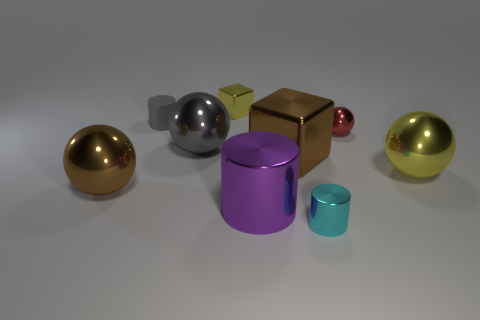Subtract 1 balls. How many balls are left? 3 Subtract all cylinders. How many objects are left? 6 Add 7 gray shiny balls. How many gray shiny balls are left? 8 Add 7 large metal cylinders. How many large metal cylinders exist? 8 Subtract 0 green cylinders. How many objects are left? 9 Subtract all shiny spheres. Subtract all tiny matte spheres. How many objects are left? 5 